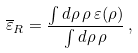<formula> <loc_0><loc_0><loc_500><loc_500>\overline { \varepsilon } _ { R } = \frac { \int d \rho \, \rho \, \varepsilon ( \rho ) } { \int d \rho \, \rho } \, ,</formula> 